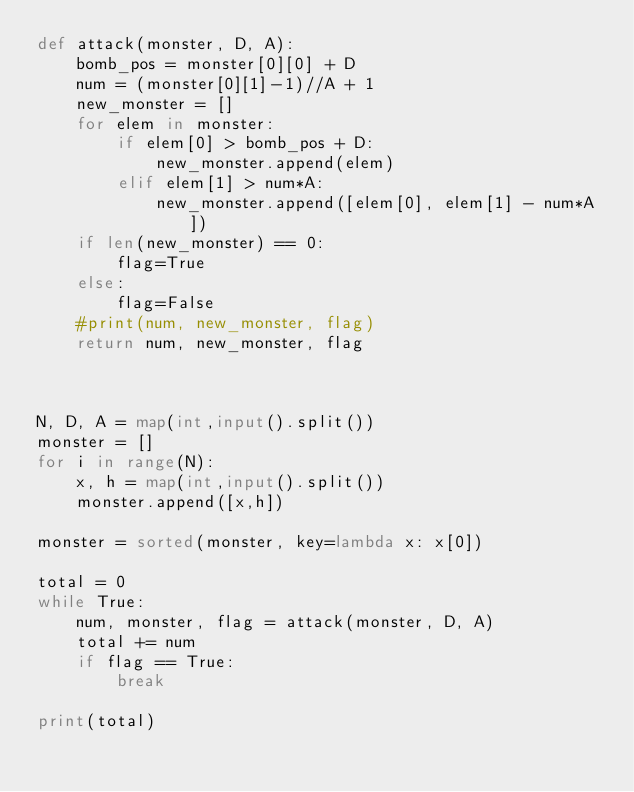Convert code to text. <code><loc_0><loc_0><loc_500><loc_500><_Python_>def attack(monster, D, A):
    bomb_pos = monster[0][0] + D
    num = (monster[0][1]-1)//A + 1
    new_monster = []
    for elem in monster:
        if elem[0] > bomb_pos + D:
            new_monster.append(elem)
        elif elem[1] > num*A:
            new_monster.append([elem[0], elem[1] - num*A])
    if len(new_monster) == 0:
        flag=True
    else:
        flag=False
    #print(num, new_monster, flag)
    return num, new_monster, flag



N, D, A = map(int,input().split())
monster = []
for i in range(N):
    x, h = map(int,input().split())
    monster.append([x,h])
    
monster = sorted(monster, key=lambda x: x[0])

total = 0
while True:
    num, monster, flag = attack(monster, D, A)
    total += num
    if flag == True:
        break

print(total)</code> 